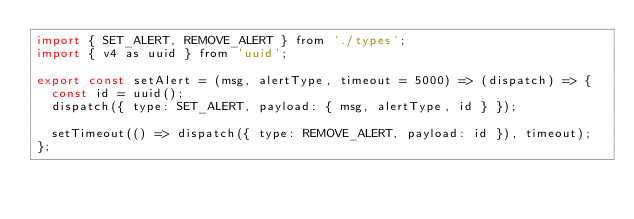<code> <loc_0><loc_0><loc_500><loc_500><_JavaScript_>import { SET_ALERT, REMOVE_ALERT } from './types';
import { v4 as uuid } from 'uuid';

export const setAlert = (msg, alertType, timeout = 5000) => (dispatch) => {
  const id = uuid();
  dispatch({ type: SET_ALERT, payload: { msg, alertType, id } });

  setTimeout(() => dispatch({ type: REMOVE_ALERT, payload: id }), timeout);
};
</code> 